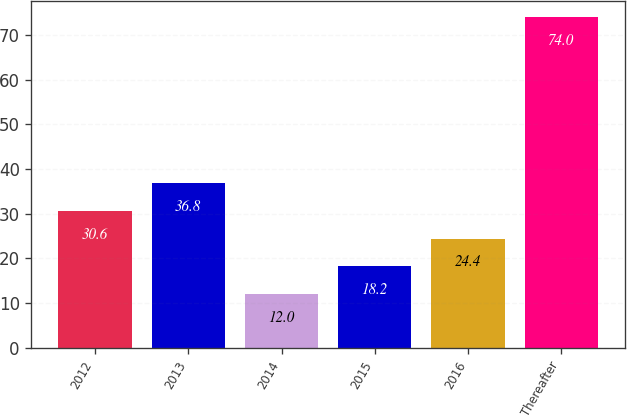Convert chart to OTSL. <chart><loc_0><loc_0><loc_500><loc_500><bar_chart><fcel>2012<fcel>2013<fcel>2014<fcel>2015<fcel>2016<fcel>Thereafter<nl><fcel>30.6<fcel>36.8<fcel>12<fcel>18.2<fcel>24.4<fcel>74<nl></chart> 